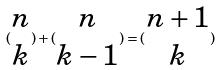Convert formula to latex. <formula><loc_0><loc_0><loc_500><loc_500>( \begin{matrix} n \\ k \end{matrix} ) + ( \begin{matrix} n \\ k - 1 \end{matrix} ) = ( \begin{matrix} n + 1 \\ k \end{matrix} )</formula> 